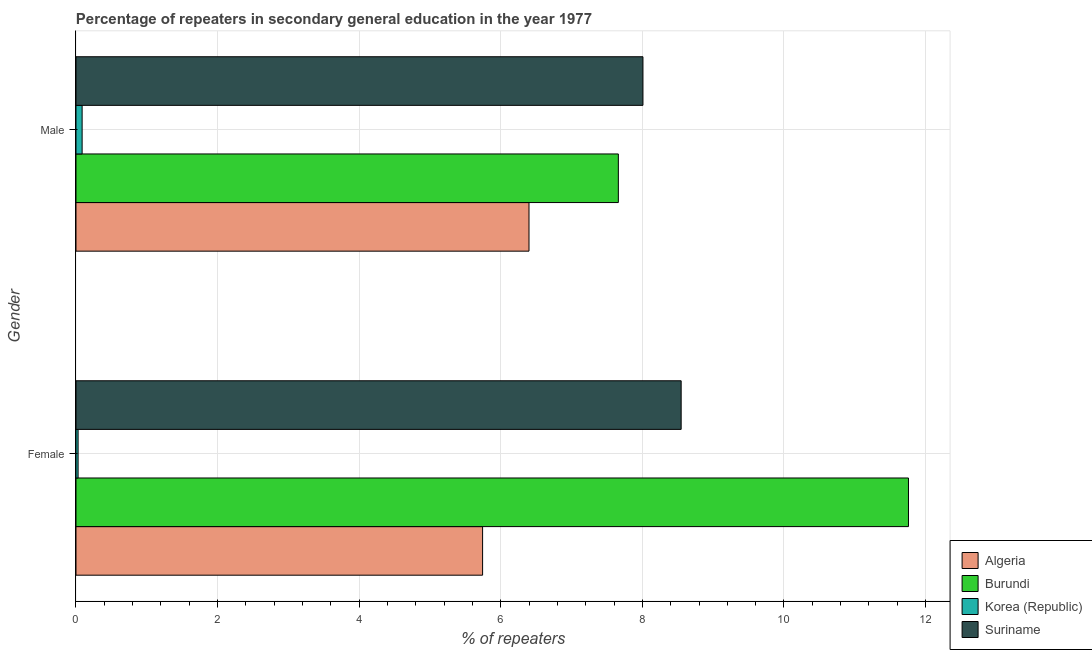How many groups of bars are there?
Make the answer very short. 2. What is the label of the 1st group of bars from the top?
Ensure brevity in your answer.  Male. What is the percentage of male repeaters in Suriname?
Offer a very short reply. 8.01. Across all countries, what is the maximum percentage of female repeaters?
Offer a very short reply. 11.76. Across all countries, what is the minimum percentage of female repeaters?
Your answer should be very brief. 0.03. In which country was the percentage of female repeaters maximum?
Your response must be concise. Burundi. What is the total percentage of male repeaters in the graph?
Make the answer very short. 22.15. What is the difference between the percentage of female repeaters in Burundi and that in Algeria?
Your answer should be very brief. 6.02. What is the difference between the percentage of female repeaters in Korea (Republic) and the percentage of male repeaters in Suriname?
Ensure brevity in your answer.  -7.98. What is the average percentage of female repeaters per country?
Make the answer very short. 6.52. What is the difference between the percentage of male repeaters and percentage of female repeaters in Burundi?
Keep it short and to the point. -4.1. In how many countries, is the percentage of male repeaters greater than 4 %?
Your answer should be very brief. 3. What is the ratio of the percentage of female repeaters in Algeria to that in Burundi?
Keep it short and to the point. 0.49. Is the percentage of female repeaters in Algeria less than that in Burundi?
Your response must be concise. Yes. What does the 3rd bar from the top in Female represents?
Provide a short and direct response. Burundi. What does the 1st bar from the bottom in Female represents?
Ensure brevity in your answer.  Algeria. How many bars are there?
Offer a very short reply. 8. How many countries are there in the graph?
Your response must be concise. 4. Does the graph contain any zero values?
Offer a terse response. No. Does the graph contain grids?
Provide a succinct answer. Yes. Where does the legend appear in the graph?
Your answer should be compact. Bottom right. How many legend labels are there?
Offer a very short reply. 4. How are the legend labels stacked?
Give a very brief answer. Vertical. What is the title of the graph?
Ensure brevity in your answer.  Percentage of repeaters in secondary general education in the year 1977. Does "Kuwait" appear as one of the legend labels in the graph?
Offer a terse response. No. What is the label or title of the X-axis?
Give a very brief answer. % of repeaters. What is the label or title of the Y-axis?
Keep it short and to the point. Gender. What is the % of repeaters of Algeria in Female?
Offer a terse response. 5.74. What is the % of repeaters of Burundi in Female?
Keep it short and to the point. 11.76. What is the % of repeaters of Korea (Republic) in Female?
Your answer should be compact. 0.03. What is the % of repeaters in Suriname in Female?
Keep it short and to the point. 8.55. What is the % of repeaters in Algeria in Male?
Offer a very short reply. 6.4. What is the % of repeaters of Burundi in Male?
Offer a very short reply. 7.66. What is the % of repeaters in Korea (Republic) in Male?
Make the answer very short. 0.09. What is the % of repeaters in Suriname in Male?
Your answer should be compact. 8.01. Across all Gender, what is the maximum % of repeaters of Algeria?
Offer a very short reply. 6.4. Across all Gender, what is the maximum % of repeaters in Burundi?
Keep it short and to the point. 11.76. Across all Gender, what is the maximum % of repeaters in Korea (Republic)?
Your answer should be compact. 0.09. Across all Gender, what is the maximum % of repeaters of Suriname?
Your answer should be very brief. 8.55. Across all Gender, what is the minimum % of repeaters of Algeria?
Offer a terse response. 5.74. Across all Gender, what is the minimum % of repeaters of Burundi?
Give a very brief answer. 7.66. Across all Gender, what is the minimum % of repeaters in Korea (Republic)?
Offer a very short reply. 0.03. Across all Gender, what is the minimum % of repeaters of Suriname?
Offer a terse response. 8.01. What is the total % of repeaters in Algeria in the graph?
Provide a short and direct response. 12.14. What is the total % of repeaters of Burundi in the graph?
Your answer should be compact. 19.42. What is the total % of repeaters in Korea (Republic) in the graph?
Give a very brief answer. 0.12. What is the total % of repeaters of Suriname in the graph?
Your answer should be compact. 16.56. What is the difference between the % of repeaters in Algeria in Female and that in Male?
Offer a very short reply. -0.66. What is the difference between the % of repeaters in Burundi in Female and that in Male?
Ensure brevity in your answer.  4.1. What is the difference between the % of repeaters in Korea (Republic) in Female and that in Male?
Your response must be concise. -0.06. What is the difference between the % of repeaters of Suriname in Female and that in Male?
Keep it short and to the point. 0.54. What is the difference between the % of repeaters in Algeria in Female and the % of repeaters in Burundi in Male?
Provide a succinct answer. -1.92. What is the difference between the % of repeaters of Algeria in Female and the % of repeaters of Korea (Republic) in Male?
Your answer should be very brief. 5.66. What is the difference between the % of repeaters in Algeria in Female and the % of repeaters in Suriname in Male?
Provide a short and direct response. -2.27. What is the difference between the % of repeaters in Burundi in Female and the % of repeaters in Korea (Republic) in Male?
Provide a short and direct response. 11.67. What is the difference between the % of repeaters of Burundi in Female and the % of repeaters of Suriname in Male?
Provide a succinct answer. 3.75. What is the difference between the % of repeaters of Korea (Republic) in Female and the % of repeaters of Suriname in Male?
Make the answer very short. -7.98. What is the average % of repeaters of Algeria per Gender?
Your answer should be compact. 6.07. What is the average % of repeaters of Burundi per Gender?
Ensure brevity in your answer.  9.71. What is the average % of repeaters of Korea (Republic) per Gender?
Offer a terse response. 0.06. What is the average % of repeaters in Suriname per Gender?
Provide a short and direct response. 8.28. What is the difference between the % of repeaters in Algeria and % of repeaters in Burundi in Female?
Ensure brevity in your answer.  -6.02. What is the difference between the % of repeaters of Algeria and % of repeaters of Korea (Republic) in Female?
Ensure brevity in your answer.  5.71. What is the difference between the % of repeaters of Algeria and % of repeaters of Suriname in Female?
Your response must be concise. -2.8. What is the difference between the % of repeaters in Burundi and % of repeaters in Korea (Republic) in Female?
Make the answer very short. 11.73. What is the difference between the % of repeaters in Burundi and % of repeaters in Suriname in Female?
Your response must be concise. 3.21. What is the difference between the % of repeaters of Korea (Republic) and % of repeaters of Suriname in Female?
Ensure brevity in your answer.  -8.52. What is the difference between the % of repeaters of Algeria and % of repeaters of Burundi in Male?
Your answer should be compact. -1.26. What is the difference between the % of repeaters in Algeria and % of repeaters in Korea (Republic) in Male?
Keep it short and to the point. 6.31. What is the difference between the % of repeaters of Algeria and % of repeaters of Suriname in Male?
Keep it short and to the point. -1.61. What is the difference between the % of repeaters in Burundi and % of repeaters in Korea (Republic) in Male?
Offer a terse response. 7.57. What is the difference between the % of repeaters in Burundi and % of repeaters in Suriname in Male?
Ensure brevity in your answer.  -0.35. What is the difference between the % of repeaters in Korea (Republic) and % of repeaters in Suriname in Male?
Give a very brief answer. -7.92. What is the ratio of the % of repeaters in Algeria in Female to that in Male?
Your response must be concise. 0.9. What is the ratio of the % of repeaters of Burundi in Female to that in Male?
Your answer should be very brief. 1.53. What is the ratio of the % of repeaters in Korea (Republic) in Female to that in Male?
Give a very brief answer. 0.34. What is the ratio of the % of repeaters of Suriname in Female to that in Male?
Provide a succinct answer. 1.07. What is the difference between the highest and the second highest % of repeaters of Algeria?
Give a very brief answer. 0.66. What is the difference between the highest and the second highest % of repeaters of Burundi?
Keep it short and to the point. 4.1. What is the difference between the highest and the second highest % of repeaters in Korea (Republic)?
Offer a terse response. 0.06. What is the difference between the highest and the second highest % of repeaters in Suriname?
Offer a very short reply. 0.54. What is the difference between the highest and the lowest % of repeaters of Algeria?
Your response must be concise. 0.66. What is the difference between the highest and the lowest % of repeaters of Burundi?
Your response must be concise. 4.1. What is the difference between the highest and the lowest % of repeaters in Korea (Republic)?
Offer a very short reply. 0.06. What is the difference between the highest and the lowest % of repeaters in Suriname?
Provide a short and direct response. 0.54. 